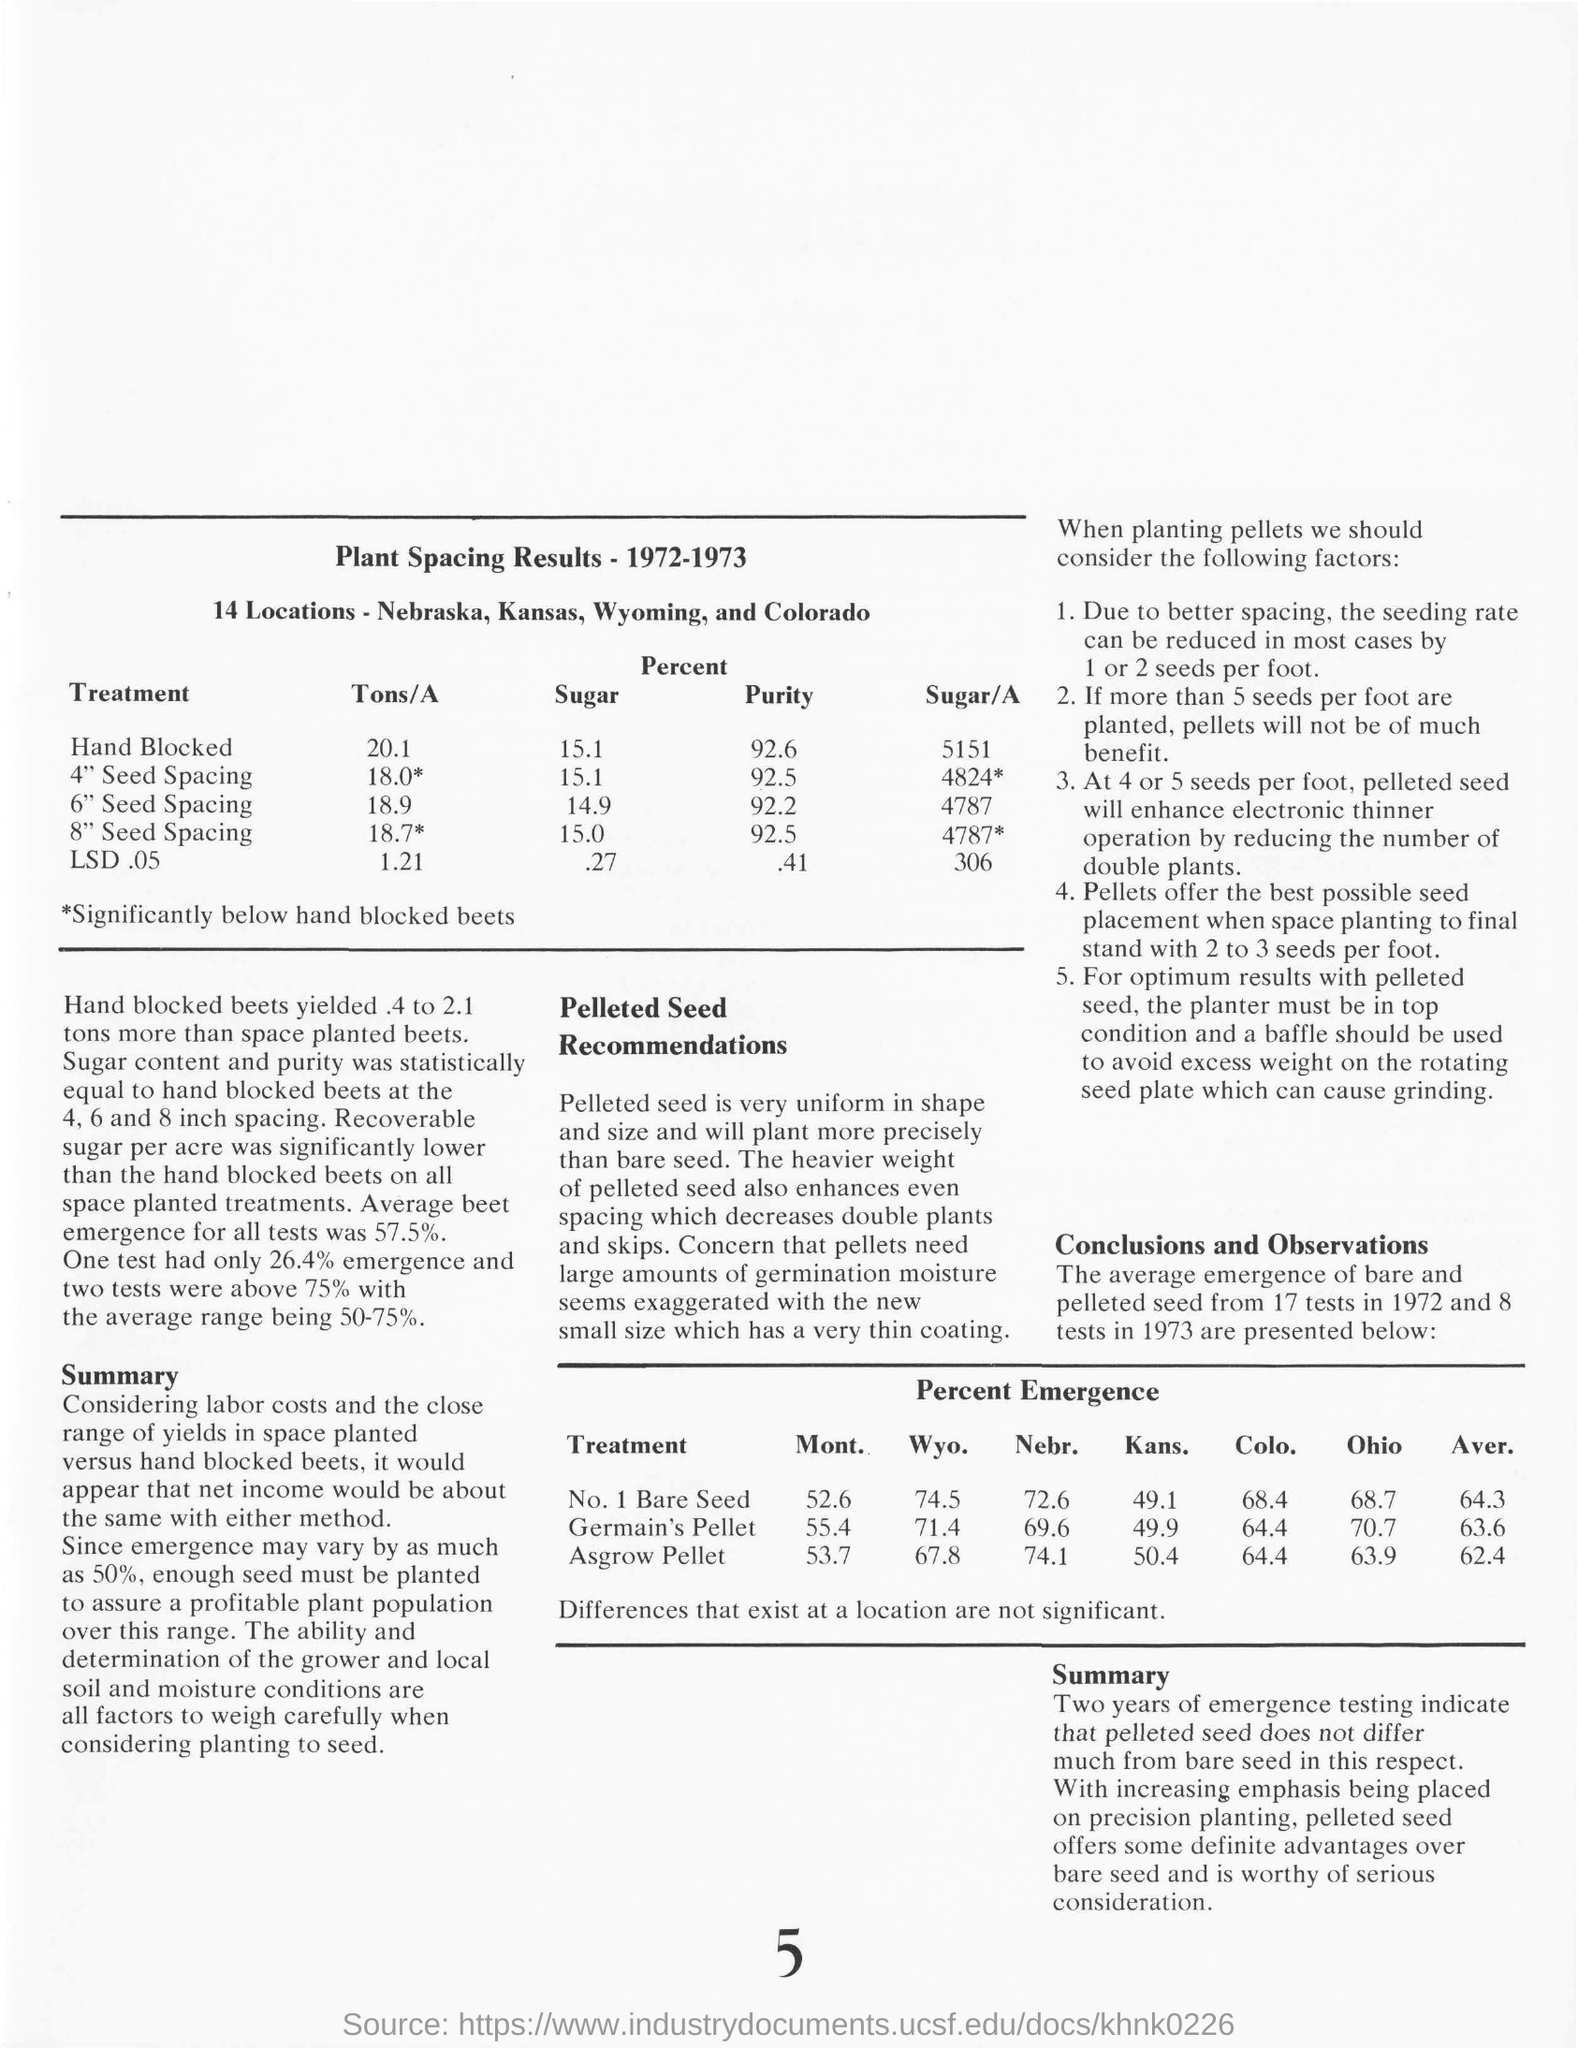What is the Page Number?
Give a very brief answer. 5. 